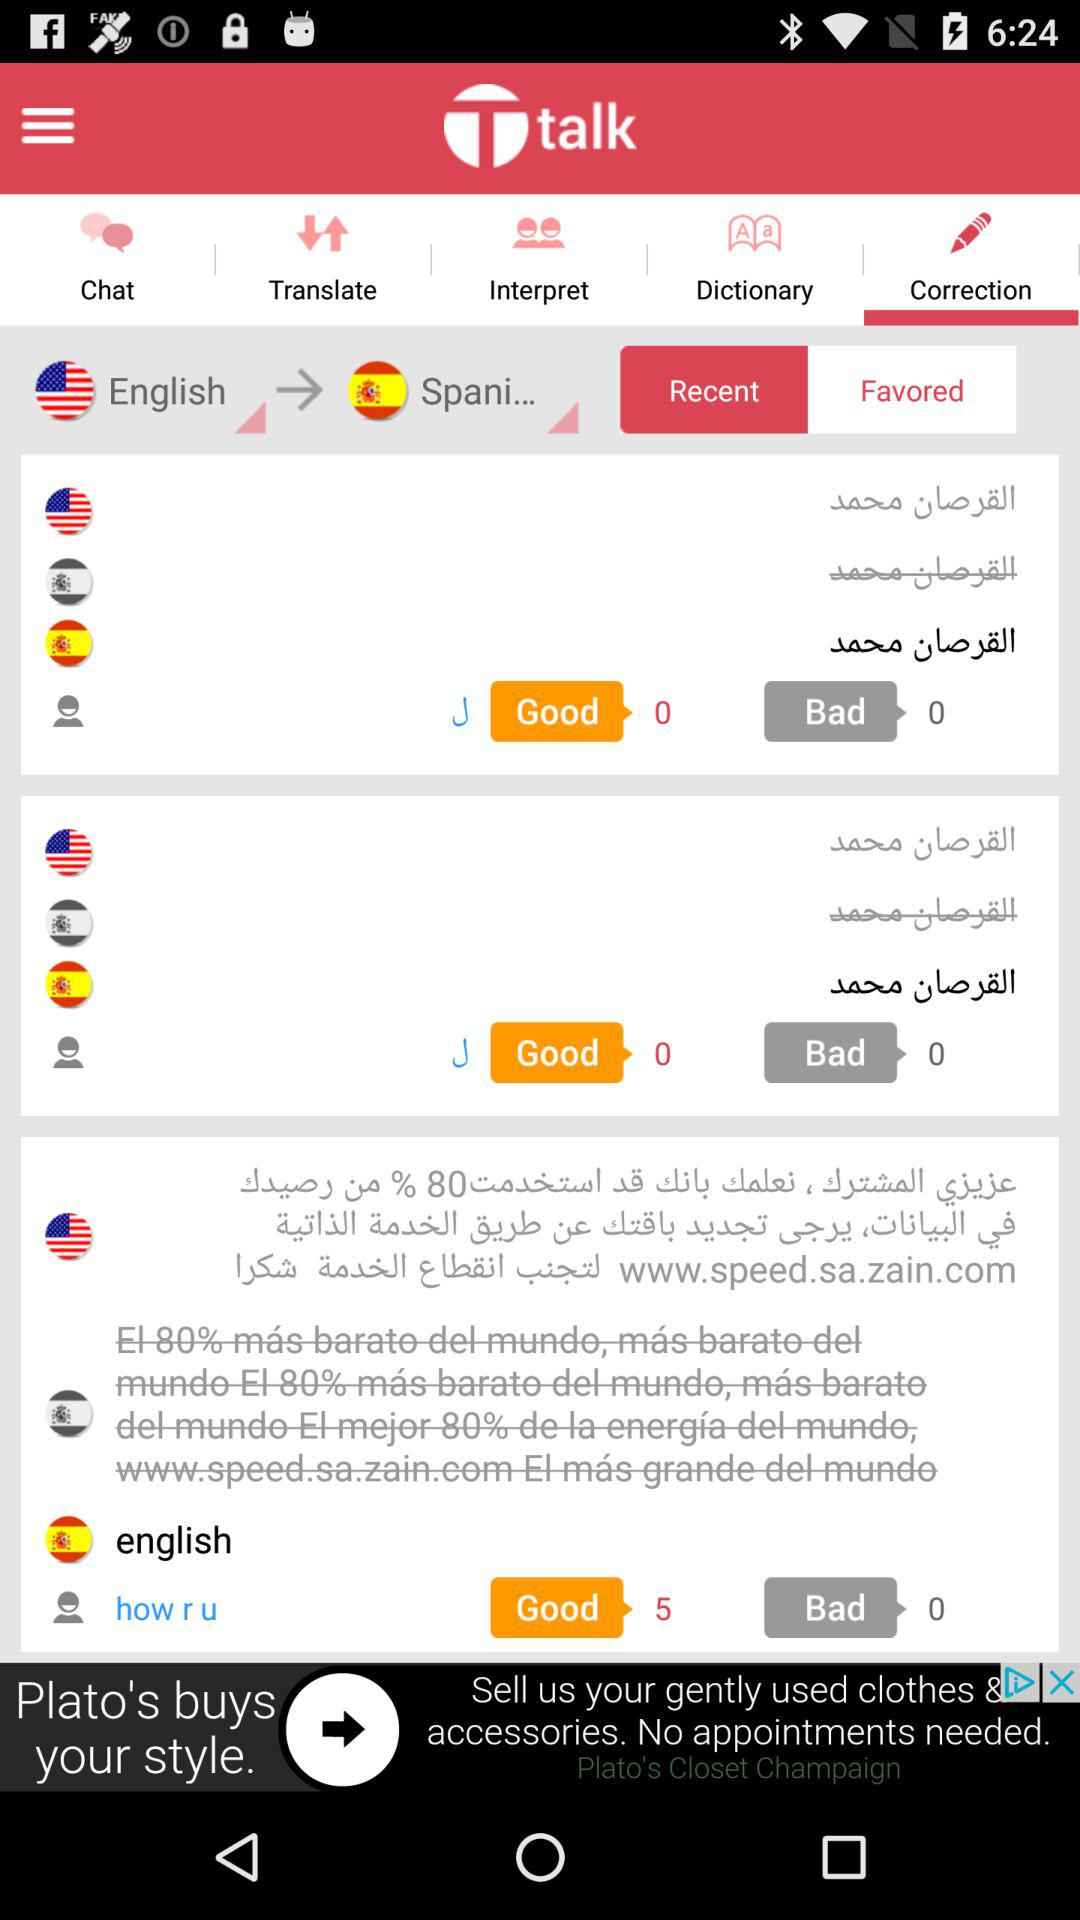Which translations were favored?
When the provided information is insufficient, respond with <no answer>. <no answer> 